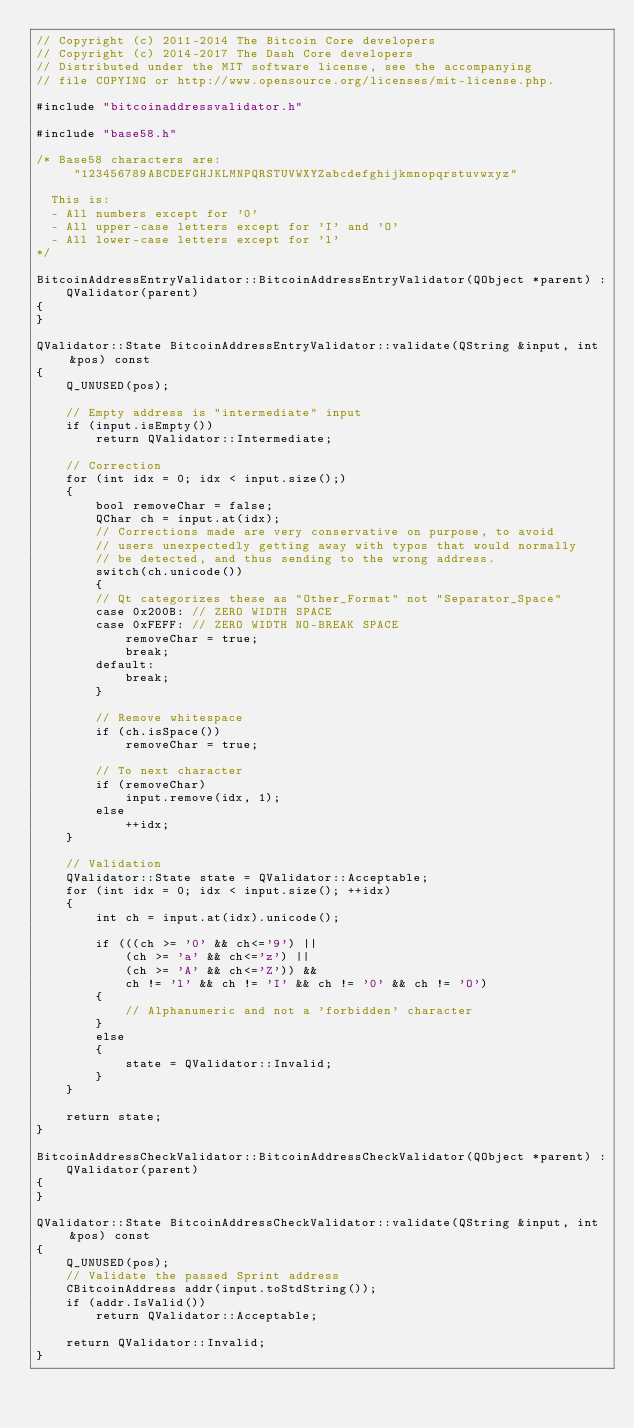Convert code to text. <code><loc_0><loc_0><loc_500><loc_500><_C++_>// Copyright (c) 2011-2014 The Bitcoin Core developers
// Copyright (c) 2014-2017 The Dash Core developers
// Distributed under the MIT software license, see the accompanying
// file COPYING or http://www.opensource.org/licenses/mit-license.php.

#include "bitcoinaddressvalidator.h"

#include "base58.h"

/* Base58 characters are:
     "123456789ABCDEFGHJKLMNPQRSTUVWXYZabcdefghijkmnopqrstuvwxyz"

  This is:
  - All numbers except for '0'
  - All upper-case letters except for 'I' and 'O'
  - All lower-case letters except for 'l'
*/

BitcoinAddressEntryValidator::BitcoinAddressEntryValidator(QObject *parent) :
    QValidator(parent)
{
}

QValidator::State BitcoinAddressEntryValidator::validate(QString &input, int &pos) const
{
    Q_UNUSED(pos);

    // Empty address is "intermediate" input
    if (input.isEmpty())
        return QValidator::Intermediate;

    // Correction
    for (int idx = 0; idx < input.size();)
    {
        bool removeChar = false;
        QChar ch = input.at(idx);
        // Corrections made are very conservative on purpose, to avoid
        // users unexpectedly getting away with typos that would normally
        // be detected, and thus sending to the wrong address.
        switch(ch.unicode())
        {
        // Qt categorizes these as "Other_Format" not "Separator_Space"
        case 0x200B: // ZERO WIDTH SPACE
        case 0xFEFF: // ZERO WIDTH NO-BREAK SPACE
            removeChar = true;
            break;
        default:
            break;
        }

        // Remove whitespace
        if (ch.isSpace())
            removeChar = true;

        // To next character
        if (removeChar)
            input.remove(idx, 1);
        else
            ++idx;
    }

    // Validation
    QValidator::State state = QValidator::Acceptable;
    for (int idx = 0; idx < input.size(); ++idx)
    {
        int ch = input.at(idx).unicode();

        if (((ch >= '0' && ch<='9') ||
            (ch >= 'a' && ch<='z') ||
            (ch >= 'A' && ch<='Z')) &&
            ch != 'l' && ch != 'I' && ch != '0' && ch != 'O')
        {
            // Alphanumeric and not a 'forbidden' character
        }
        else
        {
            state = QValidator::Invalid;
        }
    }

    return state;
}

BitcoinAddressCheckValidator::BitcoinAddressCheckValidator(QObject *parent) :
    QValidator(parent)
{
}

QValidator::State BitcoinAddressCheckValidator::validate(QString &input, int &pos) const
{
    Q_UNUSED(pos);
    // Validate the passed Sprint address
    CBitcoinAddress addr(input.toStdString());
    if (addr.IsValid())
        return QValidator::Acceptable;

    return QValidator::Invalid;
}
</code> 